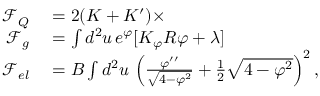<formula> <loc_0><loc_0><loc_500><loc_500>\begin{array} { r l } { \mathcal { F } _ { Q } } & = 2 ( K + K ^ { \prime } ) \times } \\ { \mathcal { F } _ { g } } & = \int d ^ { 2 } u \, e ^ { \varphi } [ K _ { \varphi } R \varphi + \lambda ] } \\ { \mathcal { F } _ { e l } } & = B \int d ^ { 2 } u \, \left ( \frac { \varphi ^ { \prime \prime } } { \sqrt { 4 - \varphi ^ { 2 } } } + \frac { 1 } { 2 } \sqrt { 4 - \varphi ^ { 2 } } \right ) ^ { 2 } , } \end{array}</formula> 